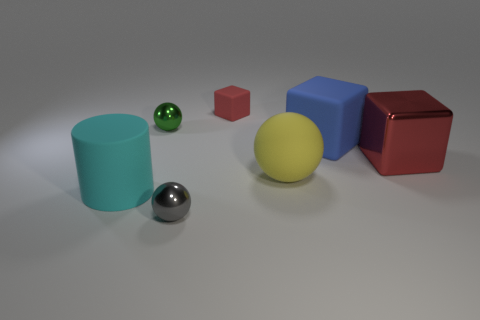Subtract all big matte cubes. How many cubes are left? 2 Subtract all red blocks. How many blocks are left? 1 Subtract all spheres. How many objects are left? 4 Subtract 2 blocks. How many blocks are left? 1 Subtract all blue cylinders. Subtract all yellow spheres. How many cylinders are left? 1 Subtract all brown cubes. How many green balls are left? 1 Subtract all big yellow rubber balls. Subtract all large cyan rubber cylinders. How many objects are left? 5 Add 6 small green things. How many small green things are left? 7 Add 5 yellow things. How many yellow things exist? 6 Add 2 blue things. How many objects exist? 9 